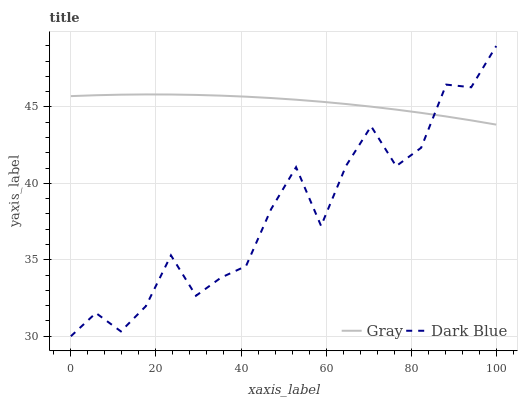Does Dark Blue have the minimum area under the curve?
Answer yes or no. Yes. Does Gray have the maximum area under the curve?
Answer yes or no. Yes. Does Dark Blue have the maximum area under the curve?
Answer yes or no. No. Is Gray the smoothest?
Answer yes or no. Yes. Is Dark Blue the roughest?
Answer yes or no. Yes. Is Dark Blue the smoothest?
Answer yes or no. No. Does Dark Blue have the lowest value?
Answer yes or no. Yes. Does Dark Blue have the highest value?
Answer yes or no. Yes. Does Gray intersect Dark Blue?
Answer yes or no. Yes. Is Gray less than Dark Blue?
Answer yes or no. No. Is Gray greater than Dark Blue?
Answer yes or no. No. 